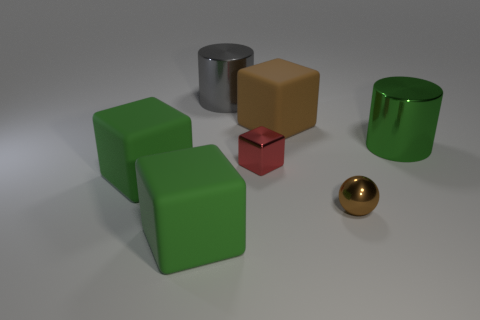Add 1 metal balls. How many objects exist? 8 Subtract all cubes. How many objects are left? 3 Subtract 1 balls. How many balls are left? 0 Subtract all yellow cubes. Subtract all gray balls. How many cubes are left? 4 Subtract all blue cubes. How many gray cylinders are left? 1 Subtract all purple blocks. Subtract all red metal blocks. How many objects are left? 6 Add 5 small brown balls. How many small brown balls are left? 6 Add 3 tiny objects. How many tiny objects exist? 5 Subtract all green blocks. How many blocks are left? 2 Subtract all large brown cubes. How many cubes are left? 3 